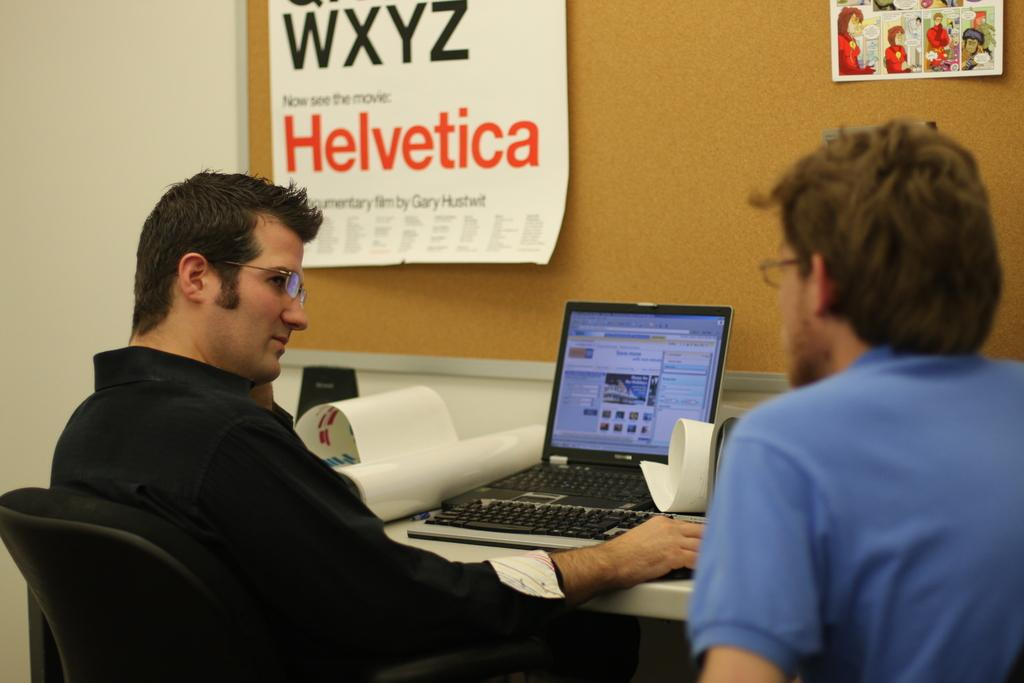<image>
Offer a succinct explanation of the picture presented. A poster with "Helvetica" in orange letters hangs on a cork board. 